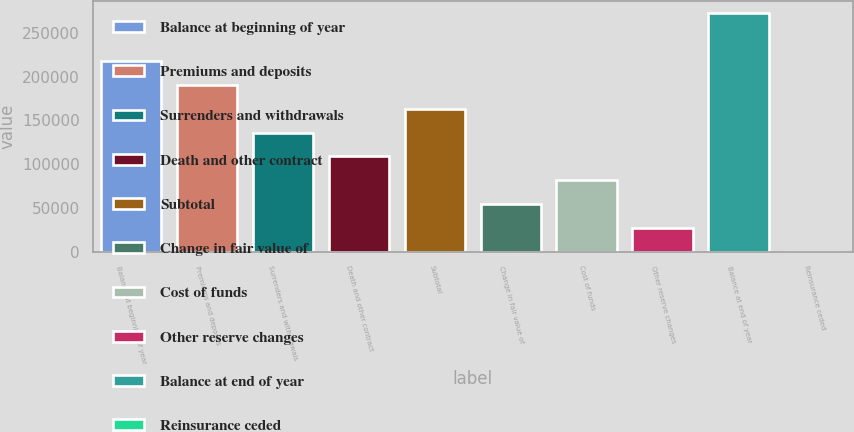Convert chart to OTSL. <chart><loc_0><loc_0><loc_500><loc_500><bar_chart><fcel>Balance at beginning of year<fcel>Premiums and deposits<fcel>Surrenders and withdrawals<fcel>Death and other contract<fcel>Subtotal<fcel>Change in fair value of<fcel>Cost of funds<fcel>Other reserve changes<fcel>Balance at end of year<fcel>Reinsurance ceded<nl><fcel>218001<fcel>190752<fcel>136252<fcel>109002<fcel>163502<fcel>54502.6<fcel>81752.4<fcel>27252.8<fcel>272501<fcel>3<nl></chart> 